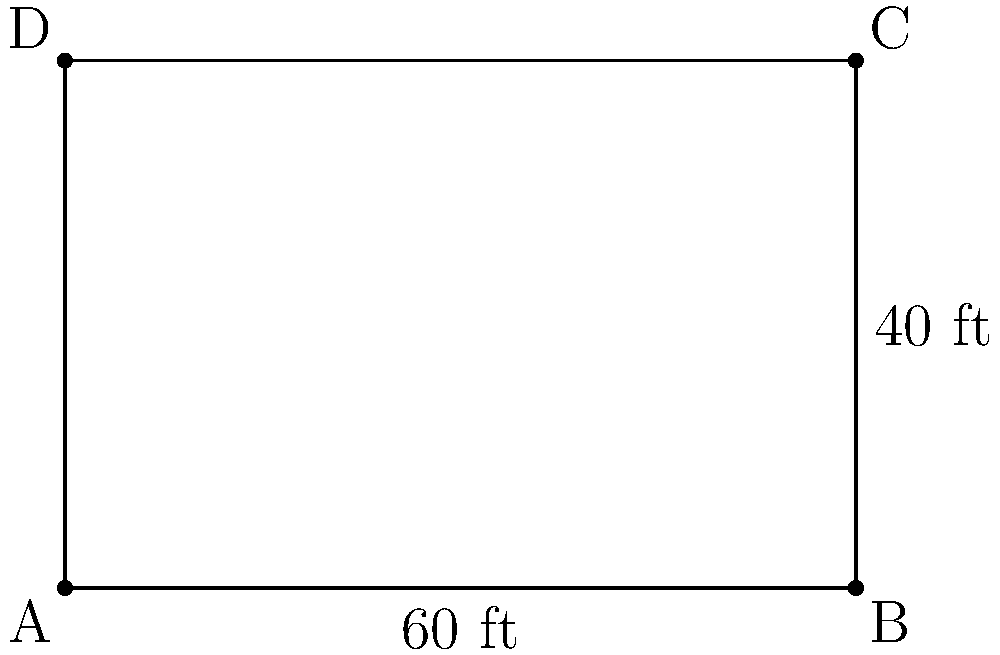A community center is planning to install a fence around its rectangular property. If the center measures 60 feet in length and 40 feet in width, what is the total length of fencing needed to enclose the entire property? To find the total length of fencing needed, we need to calculate the perimeter of the rectangular community center. Let's approach this step-by-step:

1. Identify the formula for the perimeter of a rectangle:
   $P = 2l + 2w$, where $P$ is perimeter, $l$ is length, and $w$ is width.

2. Substitute the given dimensions:
   Length $(l) = 60$ feet
   Width $(w) = 40$ feet

3. Apply the formula:
   $P = 2(60) + 2(40)$

4. Simplify:
   $P = 120 + 80$

5. Calculate the final result:
   $P = 200$

Therefore, the total length of fencing needed to enclose the entire property is 200 feet.
Answer: 200 feet 